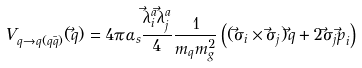Convert formula to latex. <formula><loc_0><loc_0><loc_500><loc_500>V _ { q \rightarrow q ( q \bar { q } ) } ( \vec { q } ) = 4 \pi \alpha _ { s } \frac { \vec { \lambda } _ { i } ^ { a } \vec { \lambda } _ { j } ^ { a } } { 4 } \frac { 1 } { m _ { q } m _ { g } ^ { 2 } } \left ( ( \vec { \sigma } _ { i } \times \vec { \sigma } _ { j } ) \vec { q } + 2 \vec { \sigma } _ { j } \vec { p } _ { i } \right )</formula> 